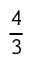<formula> <loc_0><loc_0><loc_500><loc_500>\frac { 4 } { 3 }</formula> 